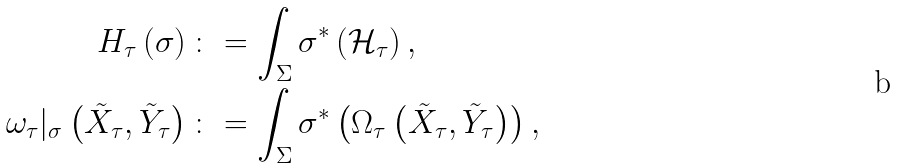Convert formula to latex. <formula><loc_0><loc_0><loc_500><loc_500>H _ { \tau } \left ( \sigma \right ) \colon & = \int _ { \Sigma } \sigma ^ { * } \left ( \mathcal { H } _ { \tau } \right ) , \\ \omega _ { \tau } | _ { \sigma } \left ( \tilde { X } _ { \tau } , \tilde { Y } _ { \tau } \right ) \colon & = \int _ { \Sigma } \sigma ^ { * } \left ( \Omega _ { \tau } \left ( \tilde { X } _ { \tau } , \tilde { Y } _ { \tau } \right ) \right ) ,</formula> 